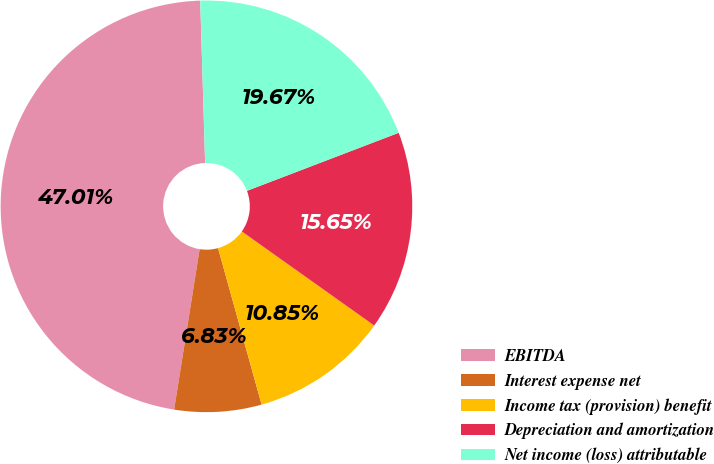<chart> <loc_0><loc_0><loc_500><loc_500><pie_chart><fcel>EBITDA<fcel>Interest expense net<fcel>Income tax (provision) benefit<fcel>Depreciation and amortization<fcel>Net income (loss) attributable<nl><fcel>47.01%<fcel>6.83%<fcel>10.85%<fcel>15.65%<fcel>19.67%<nl></chart> 